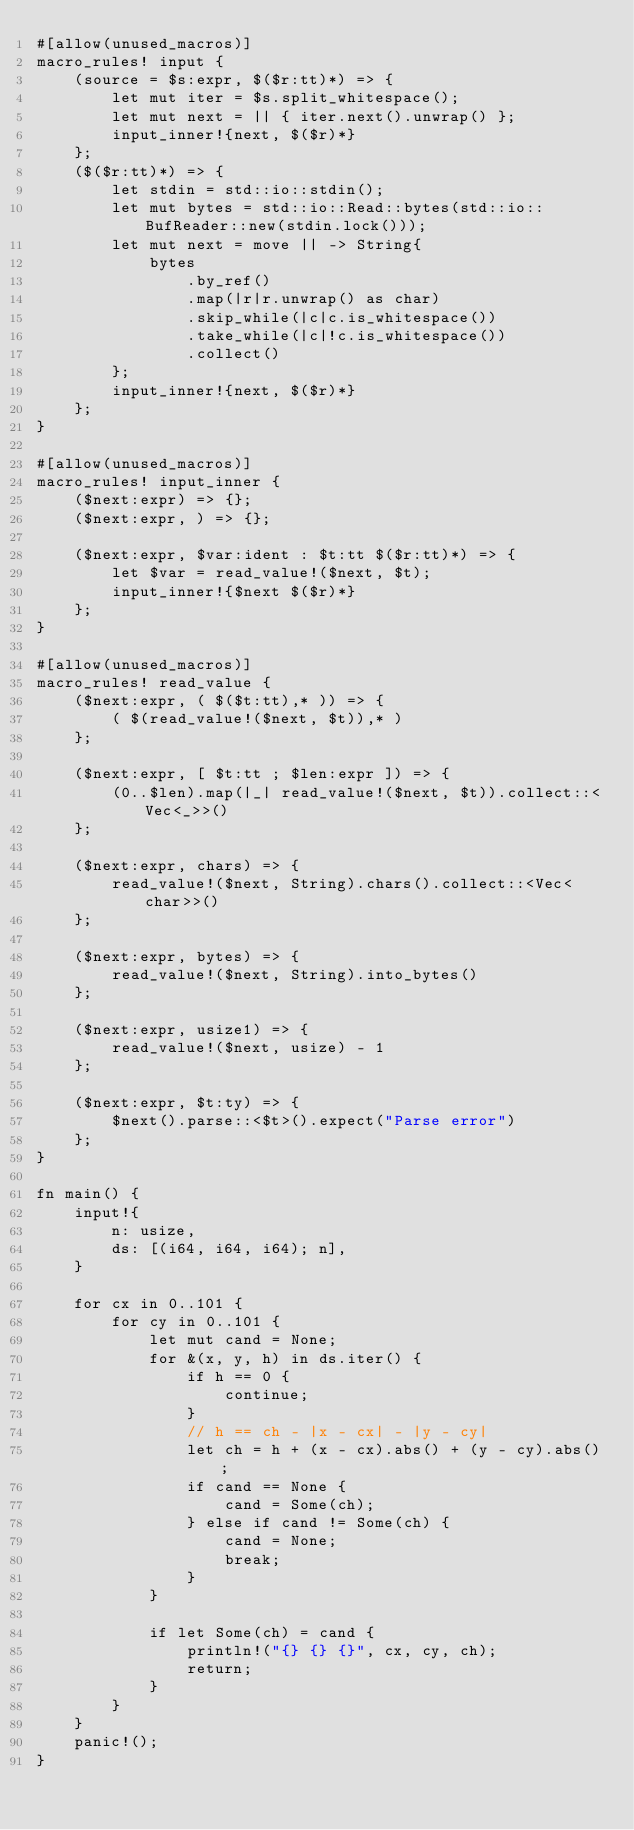Convert code to text. <code><loc_0><loc_0><loc_500><loc_500><_Rust_>#[allow(unused_macros)]
macro_rules! input {
    (source = $s:expr, $($r:tt)*) => {
        let mut iter = $s.split_whitespace();
        let mut next = || { iter.next().unwrap() };
        input_inner!{next, $($r)*}
    };
    ($($r:tt)*) => {
        let stdin = std::io::stdin();
        let mut bytes = std::io::Read::bytes(std::io::BufReader::new(stdin.lock()));
        let mut next = move || -> String{
            bytes
                .by_ref()
                .map(|r|r.unwrap() as char)
                .skip_while(|c|c.is_whitespace())
                .take_while(|c|!c.is_whitespace())
                .collect()
        };
        input_inner!{next, $($r)*}
    };
}

#[allow(unused_macros)]
macro_rules! input_inner {
    ($next:expr) => {};
    ($next:expr, ) => {};

    ($next:expr, $var:ident : $t:tt $($r:tt)*) => {
        let $var = read_value!($next, $t);
        input_inner!{$next $($r)*}
    };
}

#[allow(unused_macros)]
macro_rules! read_value {
    ($next:expr, ( $($t:tt),* )) => {
        ( $(read_value!($next, $t)),* )
    };

    ($next:expr, [ $t:tt ; $len:expr ]) => {
        (0..$len).map(|_| read_value!($next, $t)).collect::<Vec<_>>()
    };

    ($next:expr, chars) => {
        read_value!($next, String).chars().collect::<Vec<char>>()
    };

    ($next:expr, bytes) => {
        read_value!($next, String).into_bytes()
    };

    ($next:expr, usize1) => {
        read_value!($next, usize) - 1
    };

    ($next:expr, $t:ty) => {
        $next().parse::<$t>().expect("Parse error")
    };
}

fn main() {
    input!{
        n: usize,
        ds: [(i64, i64, i64); n],
    }

    for cx in 0..101 {
        for cy in 0..101 {
            let mut cand = None;
            for &(x, y, h) in ds.iter() {
                if h == 0 {
                    continue;
                }
                // h == ch - |x - cx| - |y - cy|
                let ch = h + (x - cx).abs() + (y - cy).abs();
                if cand == None {
                    cand = Some(ch);
                } else if cand != Some(ch) {
                    cand = None;
                    break;
                }
            }

            if let Some(ch) = cand {
                println!("{} {} {}", cx, cy, ch);
                return;
            }
        }
    }
    panic!();
}
</code> 